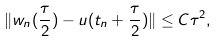<formula> <loc_0><loc_0><loc_500><loc_500>\| w _ { n } ( \frac { \tau } 2 ) - u ( t _ { n } + \frac { \tau } 2 ) \| \leq C \tau ^ { 2 } ,</formula> 